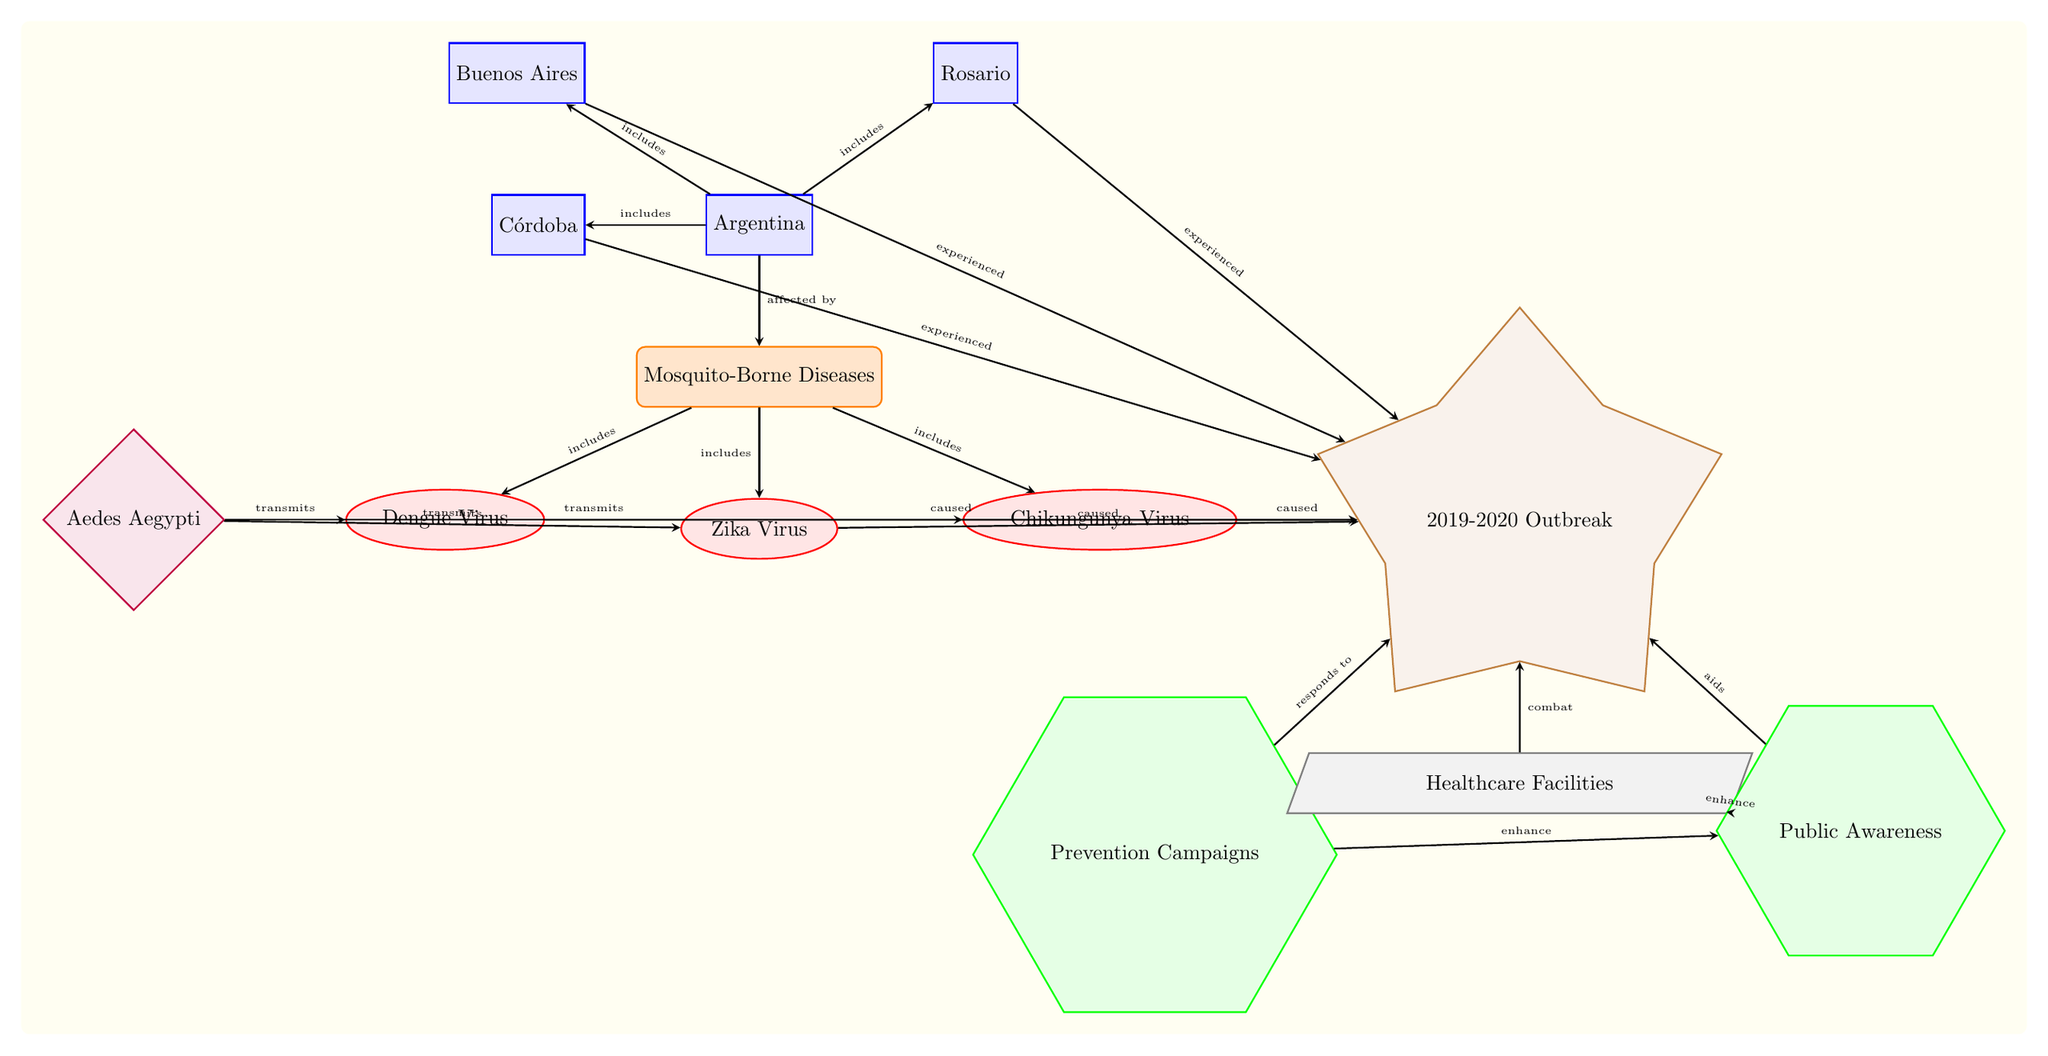What are the three mosquito-borne diseases listed? The diagram identifies three diseases: Dengue Virus, Zika Virus, and Chikungunya Virus, all represented as ellipse nodes under the main category of Mosquito-Borne Diseases.
Answer: Dengue Virus, Zika Virus, Chikungunya Virus How many locations are affected by mosquito-borne diseases in Argentina? The diagram shows four locations: Buenos Aires, Córdoba, Rosario, and Argentina itself, indicating that they are affected by the diseases listed.
Answer: 4 What mosquito species transmits all three diseases? The diagram identifies Aedes Aegypti as the vector that transmits Dengue Virus, Zika Virus, and Chikungunya Virus, as shown by the edges connecting it to each disease.
Answer: Aedes Aegypti Which event is connected to all three diseases? The event node titled "2019-2020 Outbreak" is connected by arrows to each disease, indicating that all of them were caused by this outbreak as per the diagram.
Answer: 2019-2020 Outbreak What role do healthcare facilities play in combating the outbreak? The diagram indicates that healthcare facilities are involved as they "combat" the outbreak of mosquito-borne diseases, linking them to the event. This shows their crucial role in addressing the health crisis.
Answer: Combat How do prevention campaigns relate to public awareness? According to the diagram, prevention campaigns enhance public awareness, indicating a direct relationship where efforts to prevent the diseases concurrently boost the awareness of the public.
Answer: Enhance What type of event led to the three diseases being mapped? The diagram specifies that the "2019-2020 Outbreak" is the event that caused the mapping of the diseases, demonstrating the necessity to study and respond to the situation.
Answer: Outbreak How many total actions are taken for combating the outbreak? The diagram lists two actions, namely Prevention Campaigns and Public Awareness, indicating a proactive approach to combatting the mosquito-borne diseases during the outbreak.
Answer: 2 